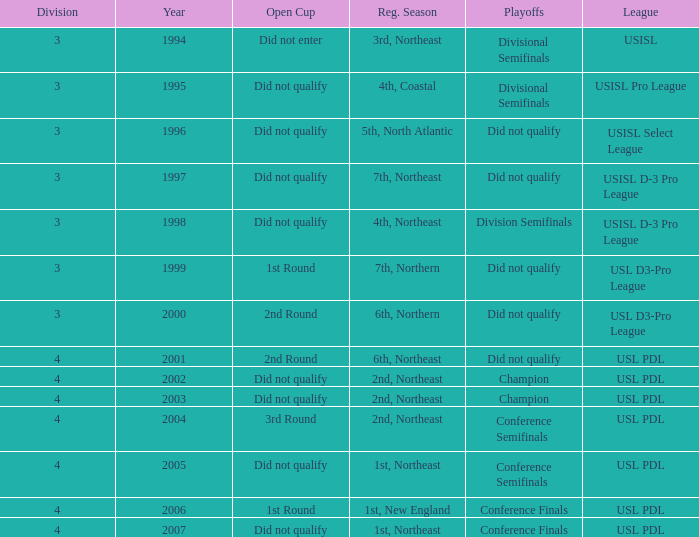Name the number of playoffs for 3rd round 1.0. 